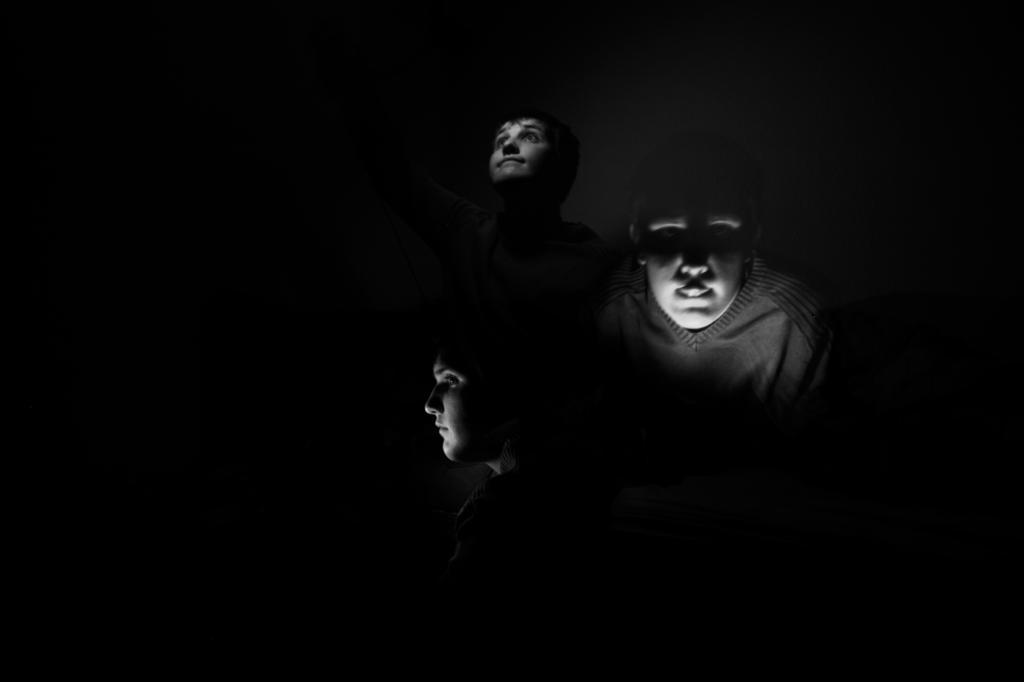In one or two sentences, can you explain what this image depicts? In this black and white picture there are three people. The image is dark. 